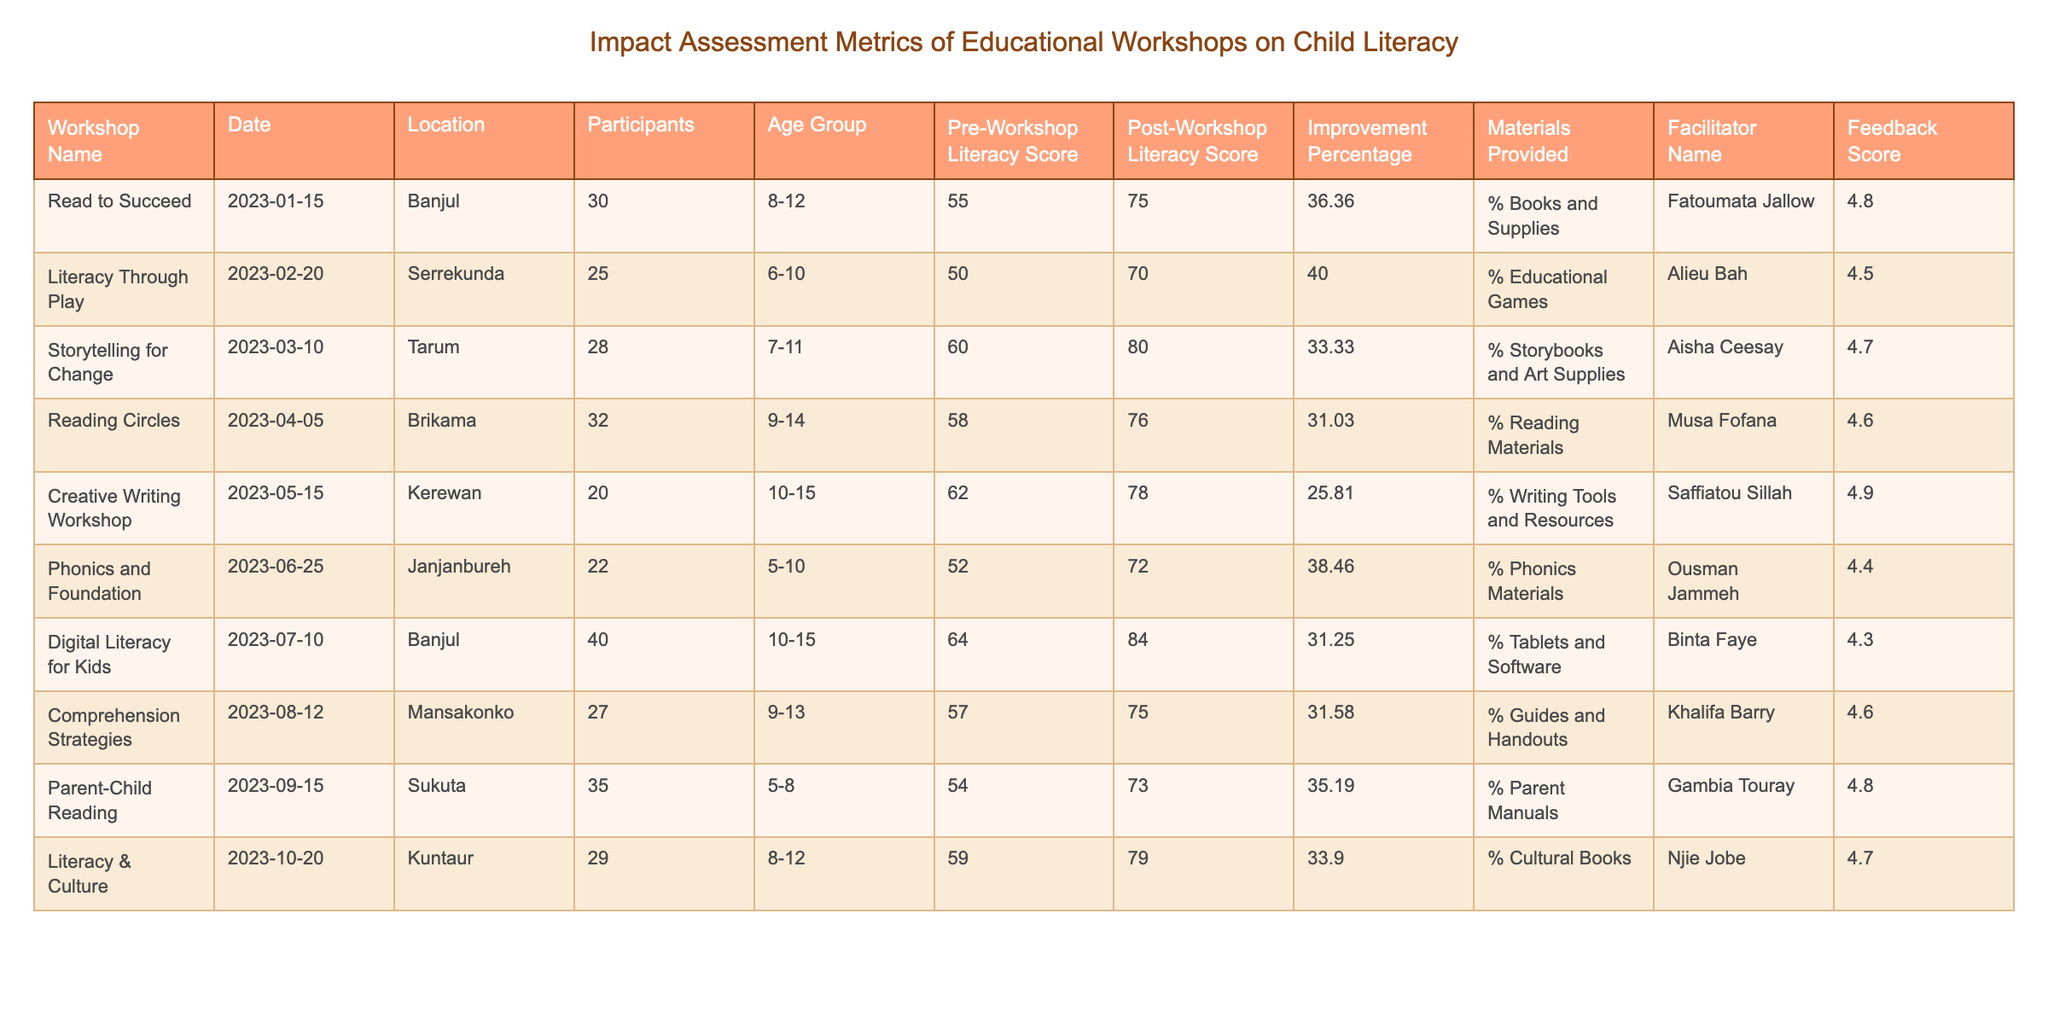What workshop took place on March 10, 2023? The table lists workshops by their date. Looking for the entry with the date "2023-03-10," the workshop is "Storytelling for Change."
Answer: Storytelling for Change What was the feedback score for the "Creative Writing Workshop"? Referring to the row for "Creative Writing Workshop," the feedback score listed is 4.9.
Answer: 4.9 How many participants were there in the "Digital Literacy for Kids" workshop? Checking the entry for "Digital Literacy for Kids," it indicates that there were 40 participants.
Answer: 40 What is the average improvement percentage across all workshops? To find the average, sum the improvement percentages: (36.36 + 40.00 + 33.33 + 31.03 + 25.81 + 38.46 + 31.25 + 31.58 + 35.19 + 33.90) =  366.81, then divide by the number of workshops (10): 366.81 / 10 = 36.68.
Answer: 36.68 Was the "Parent-Child Reading" workshop focused on children between 6 to 10 years old? The table indicates that the age group for "Parent-Child Reading" is 5-8, which is below the specified range of 6-10; therefore, the statement is false.
Answer: No Which workshop had the highest post-workshop literacy score, and what was the score? Comparing all post-workshop scores, "Digital Literacy for Kids" scored 84, which is the highest among the recorded workshops.
Answer: Digital Literacy for Kids, 84 Did the workshop "Reading Circles" result in an improvement greater than 30%? The improvement percentage for "Reading Circles" is 31.03, which is indeed greater than 30; thus, the statement is true.
Answer: Yes What was the feedback score for the workshop with the lowest pre-workshop literacy score? The workshop with the lowest pre-workshop score is "Phonics and Foundation" with a score of 52. The feedback score for this workshop is 4.4.
Answer: 4.4 Which facilitator had the most participants in their workshop? Among all workshops, "Digital Literacy for Kids" facilitated by Binta Faye had the most participants with a count of 40.
Answer: Binta Faye What is the total number of participants across all workshops? Adding all participants together: 30 + 25 + 28 + 32 + 20 + 22 + 40 + 27 + 35 + 29 =  358 participants in total.
Answer: 358 